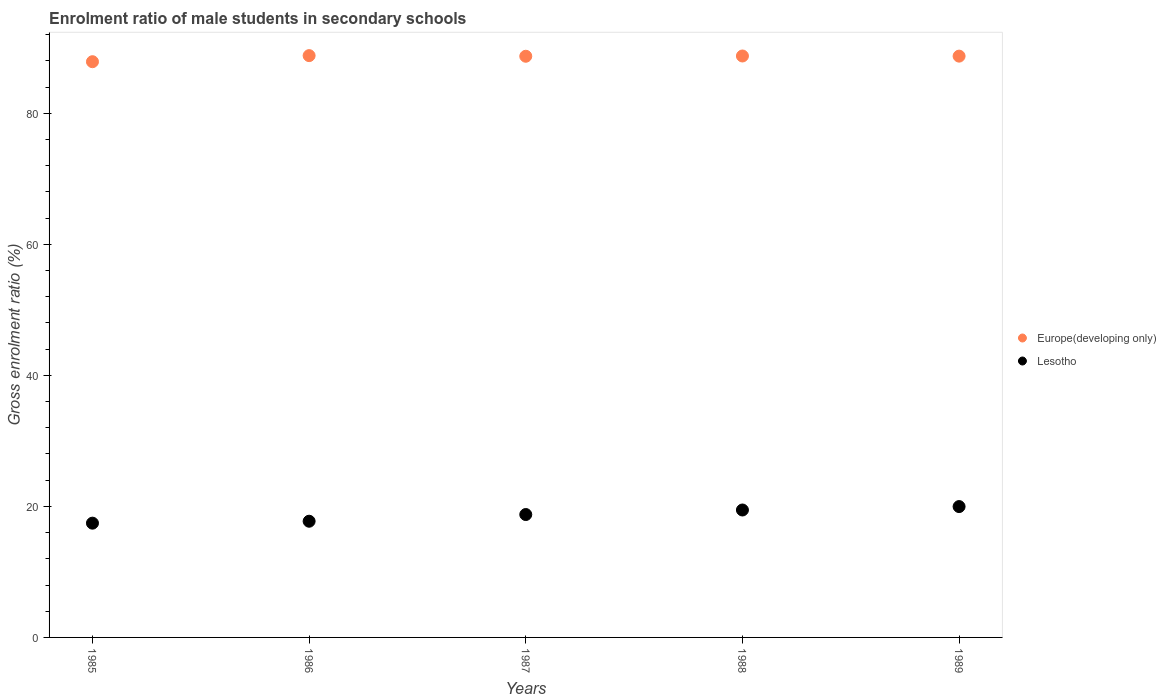Is the number of dotlines equal to the number of legend labels?
Your answer should be very brief. Yes. What is the enrolment ratio of male students in secondary schools in Lesotho in 1987?
Offer a very short reply. 18.76. Across all years, what is the maximum enrolment ratio of male students in secondary schools in Lesotho?
Provide a succinct answer. 19.97. Across all years, what is the minimum enrolment ratio of male students in secondary schools in Europe(developing only)?
Keep it short and to the point. 87.88. What is the total enrolment ratio of male students in secondary schools in Lesotho in the graph?
Offer a terse response. 93.36. What is the difference between the enrolment ratio of male students in secondary schools in Europe(developing only) in 1986 and that in 1987?
Your answer should be compact. 0.1. What is the difference between the enrolment ratio of male students in secondary schools in Lesotho in 1985 and the enrolment ratio of male students in secondary schools in Europe(developing only) in 1989?
Give a very brief answer. -71.29. What is the average enrolment ratio of male students in secondary schools in Europe(developing only) per year?
Make the answer very short. 88.57. In the year 1987, what is the difference between the enrolment ratio of male students in secondary schools in Lesotho and enrolment ratio of male students in secondary schools in Europe(developing only)?
Your answer should be very brief. -69.95. In how many years, is the enrolment ratio of male students in secondary schools in Europe(developing only) greater than 40 %?
Your response must be concise. 5. What is the ratio of the enrolment ratio of male students in secondary schools in Europe(developing only) in 1986 to that in 1987?
Your answer should be compact. 1. Is the enrolment ratio of male students in secondary schools in Europe(developing only) in 1985 less than that in 1986?
Provide a succinct answer. Yes. Is the difference between the enrolment ratio of male students in secondary schools in Lesotho in 1987 and 1988 greater than the difference between the enrolment ratio of male students in secondary schools in Europe(developing only) in 1987 and 1988?
Make the answer very short. No. What is the difference between the highest and the second highest enrolment ratio of male students in secondary schools in Europe(developing only)?
Provide a succinct answer. 0.06. What is the difference between the highest and the lowest enrolment ratio of male students in secondary schools in Europe(developing only)?
Keep it short and to the point. 0.93. In how many years, is the enrolment ratio of male students in secondary schools in Lesotho greater than the average enrolment ratio of male students in secondary schools in Lesotho taken over all years?
Keep it short and to the point. 3. Is the sum of the enrolment ratio of male students in secondary schools in Europe(developing only) in 1986 and 1989 greater than the maximum enrolment ratio of male students in secondary schools in Lesotho across all years?
Keep it short and to the point. Yes. Is the enrolment ratio of male students in secondary schools in Lesotho strictly greater than the enrolment ratio of male students in secondary schools in Europe(developing only) over the years?
Your answer should be very brief. No. How many years are there in the graph?
Your answer should be compact. 5. What is the difference between two consecutive major ticks on the Y-axis?
Your response must be concise. 20. Are the values on the major ticks of Y-axis written in scientific E-notation?
Give a very brief answer. No. Does the graph contain any zero values?
Provide a short and direct response. No. Where does the legend appear in the graph?
Give a very brief answer. Center right. How many legend labels are there?
Provide a short and direct response. 2. How are the legend labels stacked?
Provide a short and direct response. Vertical. What is the title of the graph?
Your response must be concise. Enrolment ratio of male students in secondary schools. What is the label or title of the X-axis?
Give a very brief answer. Years. What is the label or title of the Y-axis?
Give a very brief answer. Gross enrolment ratio (%). What is the Gross enrolment ratio (%) of Europe(developing only) in 1985?
Provide a succinct answer. 87.88. What is the Gross enrolment ratio (%) of Lesotho in 1985?
Keep it short and to the point. 17.44. What is the Gross enrolment ratio (%) in Europe(developing only) in 1986?
Keep it short and to the point. 88.8. What is the Gross enrolment ratio (%) in Lesotho in 1986?
Keep it short and to the point. 17.74. What is the Gross enrolment ratio (%) in Europe(developing only) in 1987?
Your answer should be very brief. 88.71. What is the Gross enrolment ratio (%) of Lesotho in 1987?
Your answer should be compact. 18.76. What is the Gross enrolment ratio (%) of Europe(developing only) in 1988?
Provide a succinct answer. 88.75. What is the Gross enrolment ratio (%) in Lesotho in 1988?
Your response must be concise. 19.45. What is the Gross enrolment ratio (%) in Europe(developing only) in 1989?
Ensure brevity in your answer.  88.73. What is the Gross enrolment ratio (%) in Lesotho in 1989?
Your answer should be very brief. 19.97. Across all years, what is the maximum Gross enrolment ratio (%) of Europe(developing only)?
Offer a terse response. 88.8. Across all years, what is the maximum Gross enrolment ratio (%) of Lesotho?
Provide a short and direct response. 19.97. Across all years, what is the minimum Gross enrolment ratio (%) in Europe(developing only)?
Your answer should be compact. 87.88. Across all years, what is the minimum Gross enrolment ratio (%) in Lesotho?
Offer a very short reply. 17.44. What is the total Gross enrolment ratio (%) in Europe(developing only) in the graph?
Provide a succinct answer. 442.86. What is the total Gross enrolment ratio (%) in Lesotho in the graph?
Offer a very short reply. 93.36. What is the difference between the Gross enrolment ratio (%) of Europe(developing only) in 1985 and that in 1986?
Provide a succinct answer. -0.93. What is the difference between the Gross enrolment ratio (%) of Lesotho in 1985 and that in 1986?
Make the answer very short. -0.29. What is the difference between the Gross enrolment ratio (%) in Europe(developing only) in 1985 and that in 1987?
Your answer should be very brief. -0.83. What is the difference between the Gross enrolment ratio (%) in Lesotho in 1985 and that in 1987?
Your response must be concise. -1.32. What is the difference between the Gross enrolment ratio (%) of Europe(developing only) in 1985 and that in 1988?
Your answer should be compact. -0.87. What is the difference between the Gross enrolment ratio (%) of Lesotho in 1985 and that in 1988?
Make the answer very short. -2.01. What is the difference between the Gross enrolment ratio (%) of Europe(developing only) in 1985 and that in 1989?
Make the answer very short. -0.85. What is the difference between the Gross enrolment ratio (%) of Lesotho in 1985 and that in 1989?
Ensure brevity in your answer.  -2.53. What is the difference between the Gross enrolment ratio (%) of Europe(developing only) in 1986 and that in 1987?
Ensure brevity in your answer.  0.1. What is the difference between the Gross enrolment ratio (%) in Lesotho in 1986 and that in 1987?
Provide a succinct answer. -1.02. What is the difference between the Gross enrolment ratio (%) of Europe(developing only) in 1986 and that in 1988?
Provide a short and direct response. 0.06. What is the difference between the Gross enrolment ratio (%) of Lesotho in 1986 and that in 1988?
Your response must be concise. -1.71. What is the difference between the Gross enrolment ratio (%) of Europe(developing only) in 1986 and that in 1989?
Provide a short and direct response. 0.08. What is the difference between the Gross enrolment ratio (%) of Lesotho in 1986 and that in 1989?
Your answer should be compact. -2.24. What is the difference between the Gross enrolment ratio (%) in Europe(developing only) in 1987 and that in 1988?
Offer a very short reply. -0.04. What is the difference between the Gross enrolment ratio (%) of Lesotho in 1987 and that in 1988?
Provide a short and direct response. -0.69. What is the difference between the Gross enrolment ratio (%) of Europe(developing only) in 1987 and that in 1989?
Provide a succinct answer. -0.02. What is the difference between the Gross enrolment ratio (%) of Lesotho in 1987 and that in 1989?
Offer a terse response. -1.21. What is the difference between the Gross enrolment ratio (%) of Europe(developing only) in 1988 and that in 1989?
Give a very brief answer. 0.02. What is the difference between the Gross enrolment ratio (%) of Lesotho in 1988 and that in 1989?
Your answer should be very brief. -0.52. What is the difference between the Gross enrolment ratio (%) of Europe(developing only) in 1985 and the Gross enrolment ratio (%) of Lesotho in 1986?
Keep it short and to the point. 70.14. What is the difference between the Gross enrolment ratio (%) in Europe(developing only) in 1985 and the Gross enrolment ratio (%) in Lesotho in 1987?
Make the answer very short. 69.12. What is the difference between the Gross enrolment ratio (%) of Europe(developing only) in 1985 and the Gross enrolment ratio (%) of Lesotho in 1988?
Your answer should be compact. 68.43. What is the difference between the Gross enrolment ratio (%) of Europe(developing only) in 1985 and the Gross enrolment ratio (%) of Lesotho in 1989?
Offer a terse response. 67.9. What is the difference between the Gross enrolment ratio (%) in Europe(developing only) in 1986 and the Gross enrolment ratio (%) in Lesotho in 1987?
Ensure brevity in your answer.  70.05. What is the difference between the Gross enrolment ratio (%) in Europe(developing only) in 1986 and the Gross enrolment ratio (%) in Lesotho in 1988?
Keep it short and to the point. 69.35. What is the difference between the Gross enrolment ratio (%) in Europe(developing only) in 1986 and the Gross enrolment ratio (%) in Lesotho in 1989?
Offer a terse response. 68.83. What is the difference between the Gross enrolment ratio (%) in Europe(developing only) in 1987 and the Gross enrolment ratio (%) in Lesotho in 1988?
Offer a very short reply. 69.26. What is the difference between the Gross enrolment ratio (%) of Europe(developing only) in 1987 and the Gross enrolment ratio (%) of Lesotho in 1989?
Offer a terse response. 68.74. What is the difference between the Gross enrolment ratio (%) in Europe(developing only) in 1988 and the Gross enrolment ratio (%) in Lesotho in 1989?
Provide a succinct answer. 68.78. What is the average Gross enrolment ratio (%) of Europe(developing only) per year?
Make the answer very short. 88.57. What is the average Gross enrolment ratio (%) of Lesotho per year?
Offer a very short reply. 18.67. In the year 1985, what is the difference between the Gross enrolment ratio (%) in Europe(developing only) and Gross enrolment ratio (%) in Lesotho?
Provide a succinct answer. 70.43. In the year 1986, what is the difference between the Gross enrolment ratio (%) of Europe(developing only) and Gross enrolment ratio (%) of Lesotho?
Provide a short and direct response. 71.07. In the year 1987, what is the difference between the Gross enrolment ratio (%) in Europe(developing only) and Gross enrolment ratio (%) in Lesotho?
Offer a terse response. 69.95. In the year 1988, what is the difference between the Gross enrolment ratio (%) in Europe(developing only) and Gross enrolment ratio (%) in Lesotho?
Keep it short and to the point. 69.3. In the year 1989, what is the difference between the Gross enrolment ratio (%) in Europe(developing only) and Gross enrolment ratio (%) in Lesotho?
Ensure brevity in your answer.  68.75. What is the ratio of the Gross enrolment ratio (%) in Lesotho in 1985 to that in 1986?
Offer a terse response. 0.98. What is the ratio of the Gross enrolment ratio (%) of Europe(developing only) in 1985 to that in 1987?
Provide a succinct answer. 0.99. What is the ratio of the Gross enrolment ratio (%) in Lesotho in 1985 to that in 1987?
Your response must be concise. 0.93. What is the ratio of the Gross enrolment ratio (%) of Europe(developing only) in 1985 to that in 1988?
Your response must be concise. 0.99. What is the ratio of the Gross enrolment ratio (%) of Lesotho in 1985 to that in 1988?
Your answer should be very brief. 0.9. What is the ratio of the Gross enrolment ratio (%) in Lesotho in 1985 to that in 1989?
Give a very brief answer. 0.87. What is the ratio of the Gross enrolment ratio (%) of Lesotho in 1986 to that in 1987?
Keep it short and to the point. 0.95. What is the ratio of the Gross enrolment ratio (%) in Lesotho in 1986 to that in 1988?
Ensure brevity in your answer.  0.91. What is the ratio of the Gross enrolment ratio (%) of Europe(developing only) in 1986 to that in 1989?
Your response must be concise. 1. What is the ratio of the Gross enrolment ratio (%) in Lesotho in 1986 to that in 1989?
Give a very brief answer. 0.89. What is the ratio of the Gross enrolment ratio (%) of Lesotho in 1987 to that in 1988?
Keep it short and to the point. 0.96. What is the ratio of the Gross enrolment ratio (%) of Europe(developing only) in 1987 to that in 1989?
Your answer should be compact. 1. What is the ratio of the Gross enrolment ratio (%) of Lesotho in 1987 to that in 1989?
Your response must be concise. 0.94. What is the ratio of the Gross enrolment ratio (%) in Europe(developing only) in 1988 to that in 1989?
Your answer should be very brief. 1. What is the ratio of the Gross enrolment ratio (%) of Lesotho in 1988 to that in 1989?
Offer a terse response. 0.97. What is the difference between the highest and the second highest Gross enrolment ratio (%) in Europe(developing only)?
Make the answer very short. 0.06. What is the difference between the highest and the second highest Gross enrolment ratio (%) of Lesotho?
Provide a succinct answer. 0.52. What is the difference between the highest and the lowest Gross enrolment ratio (%) in Europe(developing only)?
Provide a succinct answer. 0.93. What is the difference between the highest and the lowest Gross enrolment ratio (%) in Lesotho?
Your answer should be compact. 2.53. 